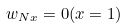Convert formula to latex. <formula><loc_0><loc_0><loc_500><loc_500>w _ { N x } = 0 ( x = 1 )</formula> 